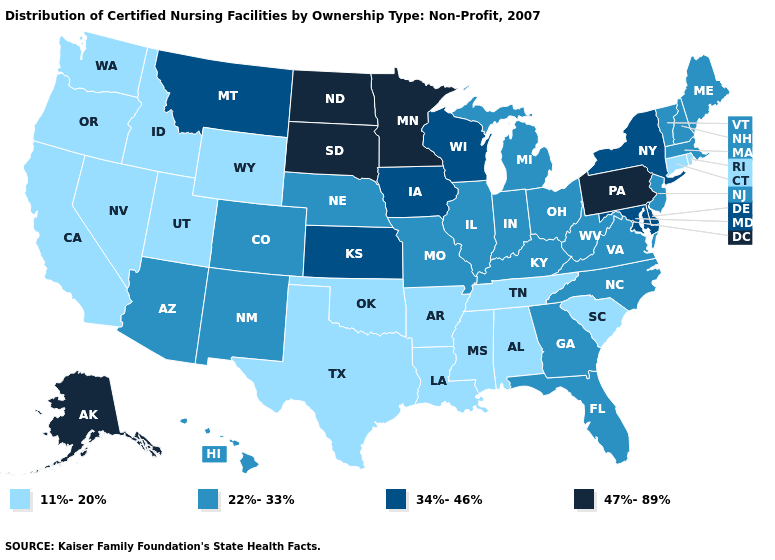What is the value of Nebraska?
Keep it brief. 22%-33%. Which states hav the highest value in the MidWest?
Keep it brief. Minnesota, North Dakota, South Dakota. What is the value of Kansas?
Short answer required. 34%-46%. Among the states that border Ohio , which have the lowest value?
Short answer required. Indiana, Kentucky, Michigan, West Virginia. What is the highest value in the West ?
Concise answer only. 47%-89%. Name the states that have a value in the range 47%-89%?
Keep it brief. Alaska, Minnesota, North Dakota, Pennsylvania, South Dakota. Does Utah have a lower value than Rhode Island?
Quick response, please. No. Which states have the lowest value in the South?
Write a very short answer. Alabama, Arkansas, Louisiana, Mississippi, Oklahoma, South Carolina, Tennessee, Texas. What is the highest value in states that border Massachusetts?
Give a very brief answer. 34%-46%. Name the states that have a value in the range 34%-46%?
Keep it brief. Delaware, Iowa, Kansas, Maryland, Montana, New York, Wisconsin. Does New Jersey have the highest value in the Northeast?
Be succinct. No. Name the states that have a value in the range 22%-33%?
Answer briefly. Arizona, Colorado, Florida, Georgia, Hawaii, Illinois, Indiana, Kentucky, Maine, Massachusetts, Michigan, Missouri, Nebraska, New Hampshire, New Jersey, New Mexico, North Carolina, Ohio, Vermont, Virginia, West Virginia. Among the states that border Illinois , which have the highest value?
Write a very short answer. Iowa, Wisconsin. What is the lowest value in the Northeast?
Quick response, please. 11%-20%. 